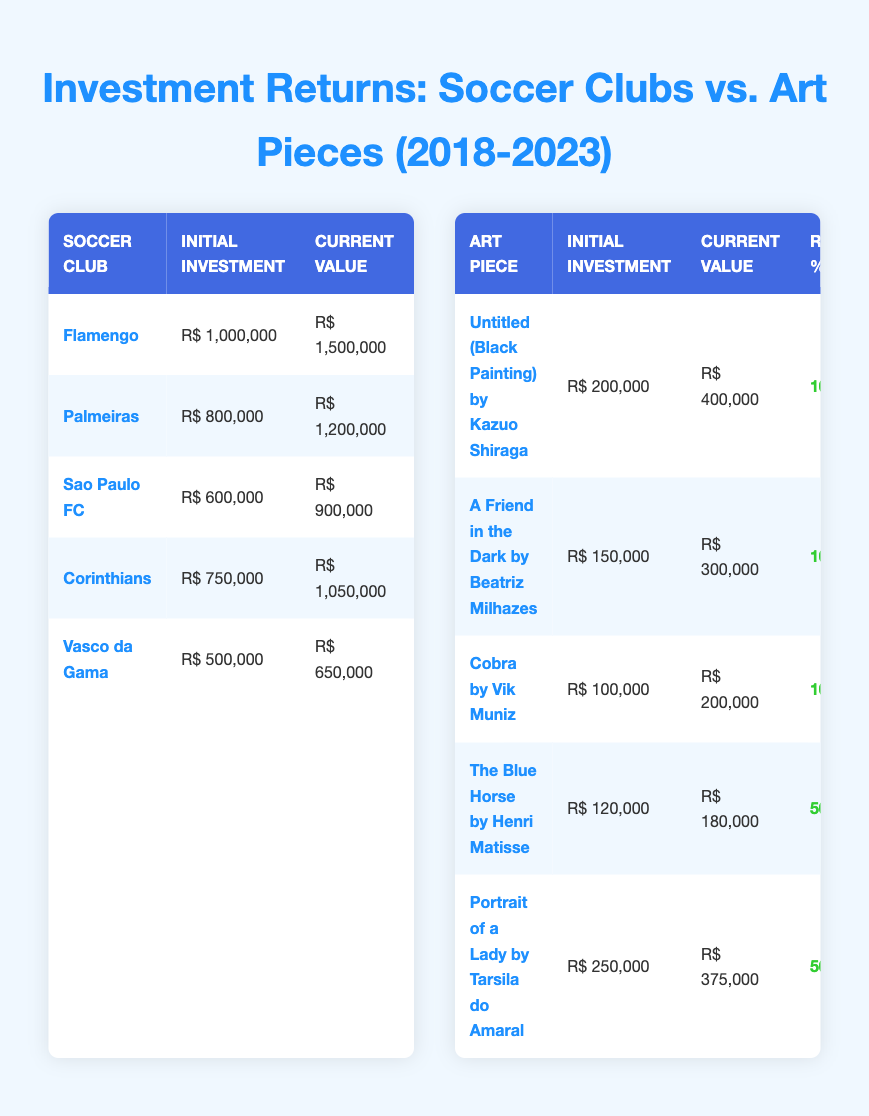What is the current value of Flamengo in the investment table? The current value of Flamengo is mentioned directly in the table. It is listed as R$ 1,500,000.
Answer: R$ 1,500,000 Which art piece has the highest return percentage? According to the table, both "Untitled (Black Painting) by Kazuo Shiraga" and "A Friend in the Dark by Beatriz Milhazes" have the highest return percentage of 100%.
Answer: 100% What is the total initial investment in soccer clubs? To find the total initial investment, we sum the initial investments of all soccer clubs: R$ 1,000,000 + R$ 800,000 + R$ 600,000 + R$ 750,000 + R$ 500,000 = R$ 2,650,000.
Answer: R$ 2,650,000 Is the return percentage of Vasco da Gama higher than that of Corinthians? Vasco da Gama has a return percentage of 30%, while Corinthians has a return percentage of 40%. Since 30% is not higher than 40%, the answer is no.
Answer: No What is the average current value of art pieces? The current values of the art pieces are R$ 400,000, R$ 300,000, R$ 200,000, R$ 180,000, and R$ 375,000. First, we sum these values: R$ 400,000 + R$ 300,000 + R$ 200,000 + R$ 180,000 + R$ 375,000 = R$ 1,455,000. Next, we divide by the number of art pieces, which is 5, leading to an average of R$ 1,455,000 / 5 = R$ 291,000.
Answer: R$ 291,000 Which soccer club has the same return percentage as Sao Paulo FC? Sao Paulo FC has a return percentage of 50%. According to the table, both Flamengo and Palmeiras also have the same return percentage of 50%.
Answer: Flamengo and Palmeiras Did any of the art pieces have a return percentage below 50%? From the table, the only art pieces with a return percentage below 50% are "The Blue Horse by Henri Matisse" and "Portrait of a Lady by Tarsila do Amaral," both at 50%. Since there are no pieces below 50%, the answer is no.
Answer: No What is the difference between the total current value of soccer clubs and the total current value of art pieces? The total current value of soccer clubs is R$ 1,500,000 + R$ 1,200,000 + R$ 900,000 + R$ 1,050,000 + R$ 650,000 = R$ 5,400,000. The total current value of art pieces is R$ 400,000 + R$ 300,000 + R$ 200,000 + R$ 180,000 + R$ 375,000 = R$ 1,455,000. The difference is R$ 5,400,000 - R$ 1,455,000 = R$ 3,945,000.
Answer: R$ 3,945,000 